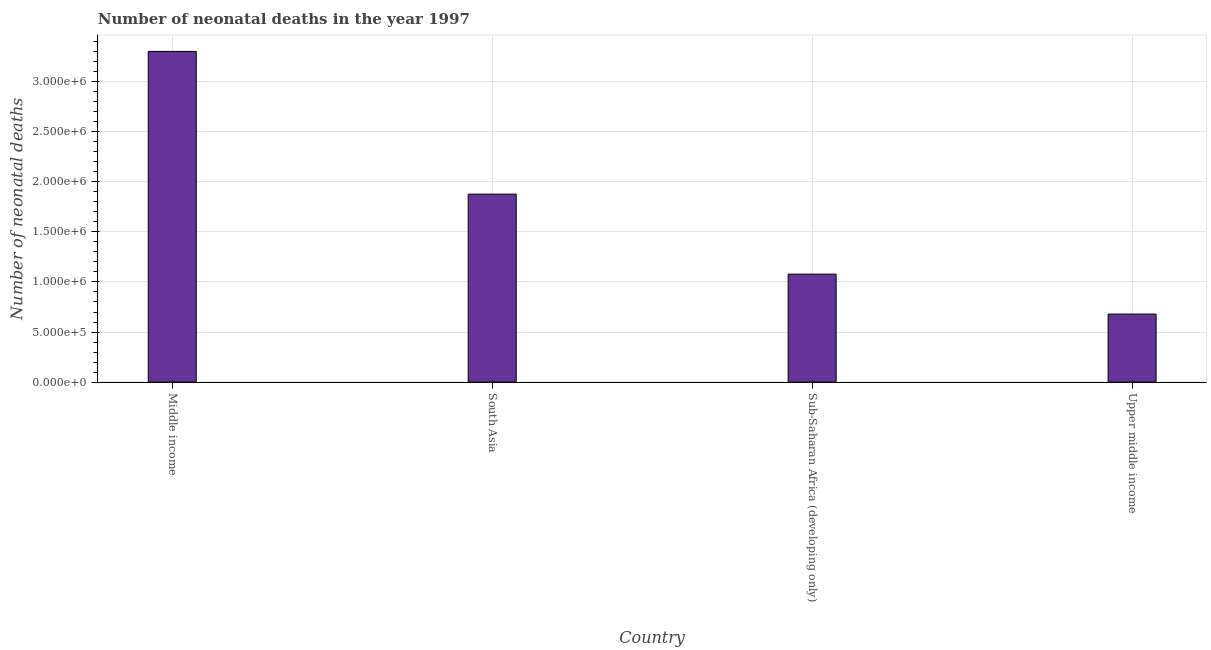Does the graph contain any zero values?
Your answer should be very brief. No. What is the title of the graph?
Provide a succinct answer. Number of neonatal deaths in the year 1997. What is the label or title of the X-axis?
Your response must be concise. Country. What is the label or title of the Y-axis?
Your answer should be compact. Number of neonatal deaths. What is the number of neonatal deaths in South Asia?
Give a very brief answer. 1.88e+06. Across all countries, what is the maximum number of neonatal deaths?
Your answer should be very brief. 3.30e+06. Across all countries, what is the minimum number of neonatal deaths?
Make the answer very short. 6.79e+05. In which country was the number of neonatal deaths maximum?
Your response must be concise. Middle income. In which country was the number of neonatal deaths minimum?
Provide a succinct answer. Upper middle income. What is the sum of the number of neonatal deaths?
Your response must be concise. 6.94e+06. What is the difference between the number of neonatal deaths in Middle income and Upper middle income?
Provide a succinct answer. 2.62e+06. What is the average number of neonatal deaths per country?
Ensure brevity in your answer.  1.73e+06. What is the median number of neonatal deaths?
Your response must be concise. 1.48e+06. In how many countries, is the number of neonatal deaths greater than 2600000 ?
Offer a very short reply. 1. What is the ratio of the number of neonatal deaths in South Asia to that in Sub-Saharan Africa (developing only)?
Make the answer very short. 1.74. What is the difference between the highest and the second highest number of neonatal deaths?
Your answer should be compact. 1.42e+06. Is the sum of the number of neonatal deaths in Sub-Saharan Africa (developing only) and Upper middle income greater than the maximum number of neonatal deaths across all countries?
Your answer should be compact. No. What is the difference between the highest and the lowest number of neonatal deaths?
Make the answer very short. 2.62e+06. In how many countries, is the number of neonatal deaths greater than the average number of neonatal deaths taken over all countries?
Your answer should be compact. 2. How many countries are there in the graph?
Your answer should be compact. 4. What is the difference between two consecutive major ticks on the Y-axis?
Your answer should be compact. 5.00e+05. What is the Number of neonatal deaths in Middle income?
Offer a terse response. 3.30e+06. What is the Number of neonatal deaths in South Asia?
Offer a very short reply. 1.88e+06. What is the Number of neonatal deaths in Sub-Saharan Africa (developing only)?
Offer a terse response. 1.08e+06. What is the Number of neonatal deaths of Upper middle income?
Your answer should be compact. 6.79e+05. What is the difference between the Number of neonatal deaths in Middle income and South Asia?
Give a very brief answer. 1.42e+06. What is the difference between the Number of neonatal deaths in Middle income and Sub-Saharan Africa (developing only)?
Offer a terse response. 2.22e+06. What is the difference between the Number of neonatal deaths in Middle income and Upper middle income?
Offer a very short reply. 2.62e+06. What is the difference between the Number of neonatal deaths in South Asia and Sub-Saharan Africa (developing only)?
Your answer should be compact. 7.99e+05. What is the difference between the Number of neonatal deaths in South Asia and Upper middle income?
Provide a short and direct response. 1.20e+06. What is the difference between the Number of neonatal deaths in Sub-Saharan Africa (developing only) and Upper middle income?
Give a very brief answer. 3.99e+05. What is the ratio of the Number of neonatal deaths in Middle income to that in South Asia?
Make the answer very short. 1.76. What is the ratio of the Number of neonatal deaths in Middle income to that in Sub-Saharan Africa (developing only)?
Give a very brief answer. 3.06. What is the ratio of the Number of neonatal deaths in Middle income to that in Upper middle income?
Give a very brief answer. 4.86. What is the ratio of the Number of neonatal deaths in South Asia to that in Sub-Saharan Africa (developing only)?
Provide a short and direct response. 1.74. What is the ratio of the Number of neonatal deaths in South Asia to that in Upper middle income?
Provide a short and direct response. 2.76. What is the ratio of the Number of neonatal deaths in Sub-Saharan Africa (developing only) to that in Upper middle income?
Ensure brevity in your answer.  1.59. 